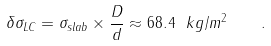<formula> <loc_0><loc_0><loc_500><loc_500>\delta \sigma _ { L C } = \sigma _ { s l a b } \times \frac { D } { d } \approx 6 8 . 4 \ k g / m ^ { 2 } \quad .</formula> 